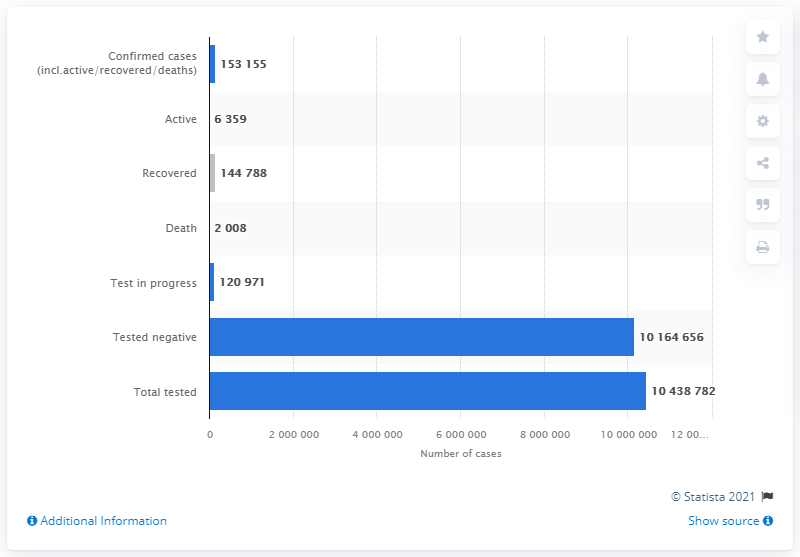Highlight a few significant elements in this photo. As of February 20th, a total of 104,387,826 people have been tested for COVID-19 globally. 